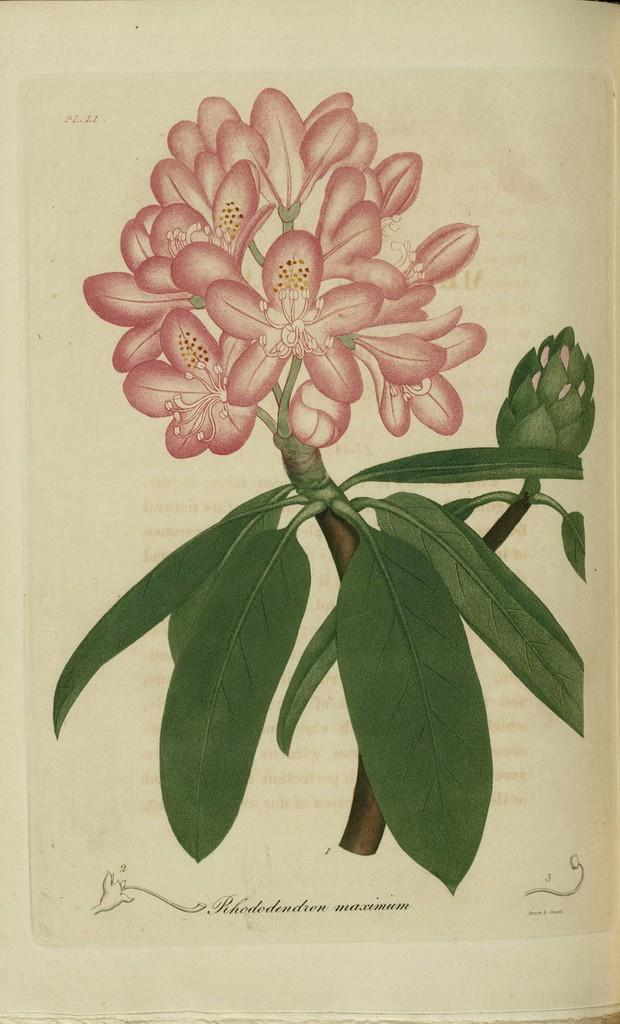What type of artwork is shown in the image? The image is a painting. What is the main subject of the painting? The painting depicts flowers. Are there any other elements in the painting besides flowers? Yes, the painting includes green leaves. How many bikes are included in the painting? There are no bikes present in the painting; it features flowers and green leaves. 